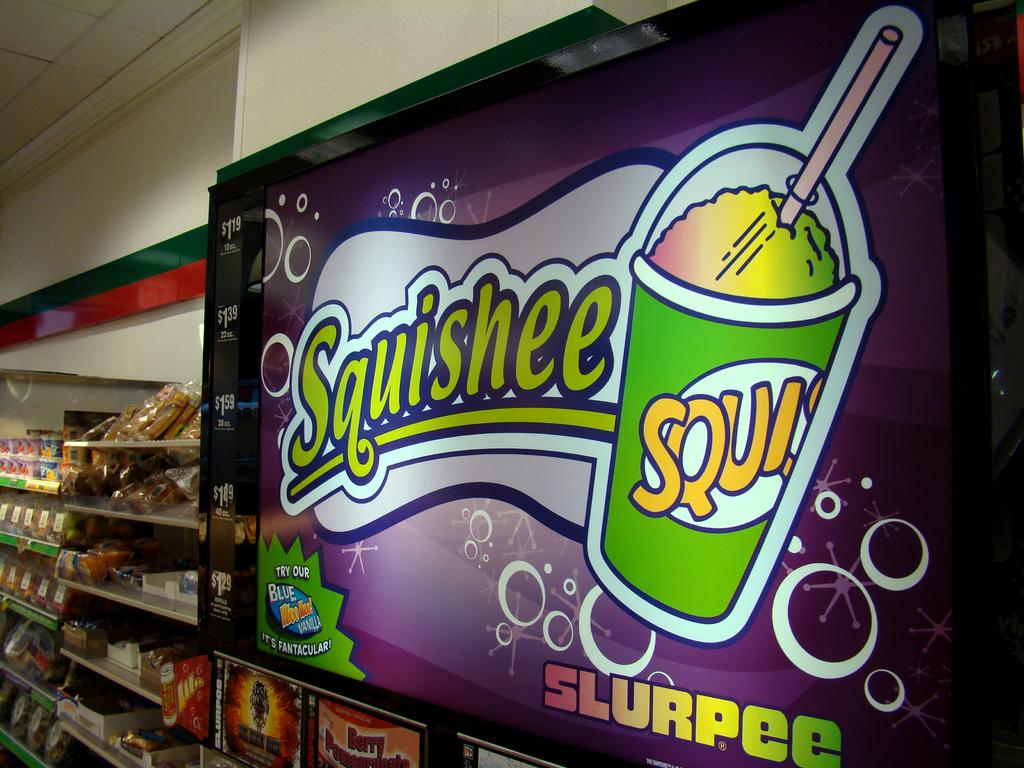What kind of beverage is shown?
Your answer should be very brief. Squishee. What is the brand name at the bottom?
Keep it short and to the point. Slurpee. 